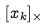<formula> <loc_0><loc_0><loc_500><loc_500>[ x _ { k } ] _ { \times }</formula> 